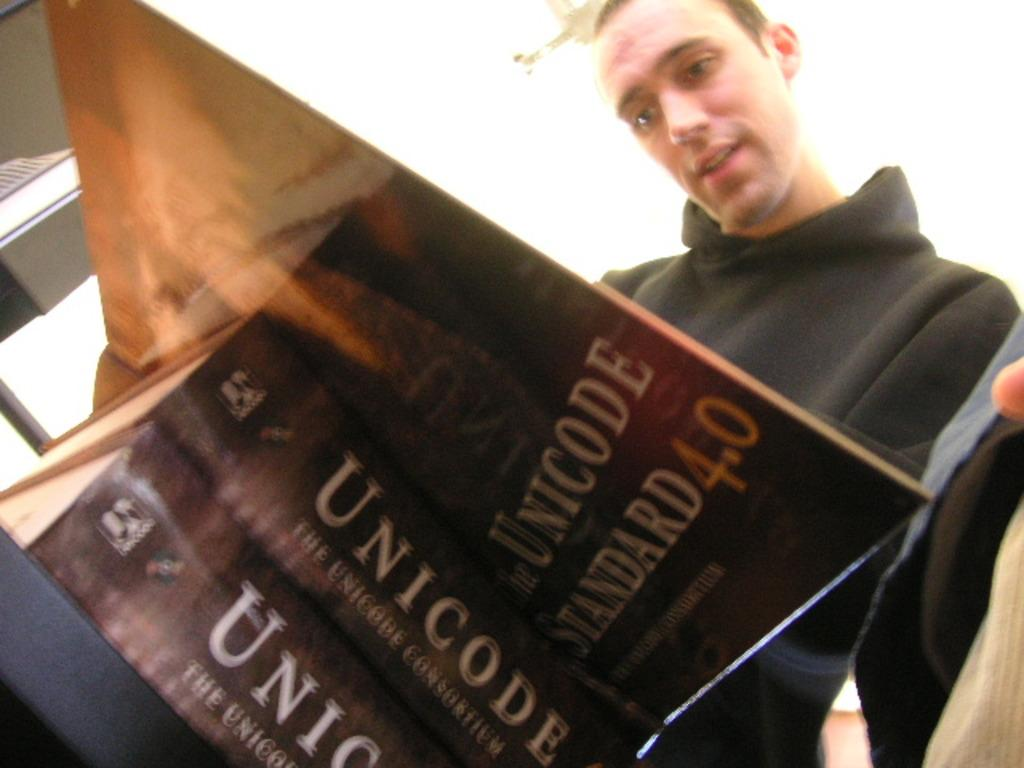<image>
Render a clear and concise summary of the photo. a man reading out of a book called Unicode 